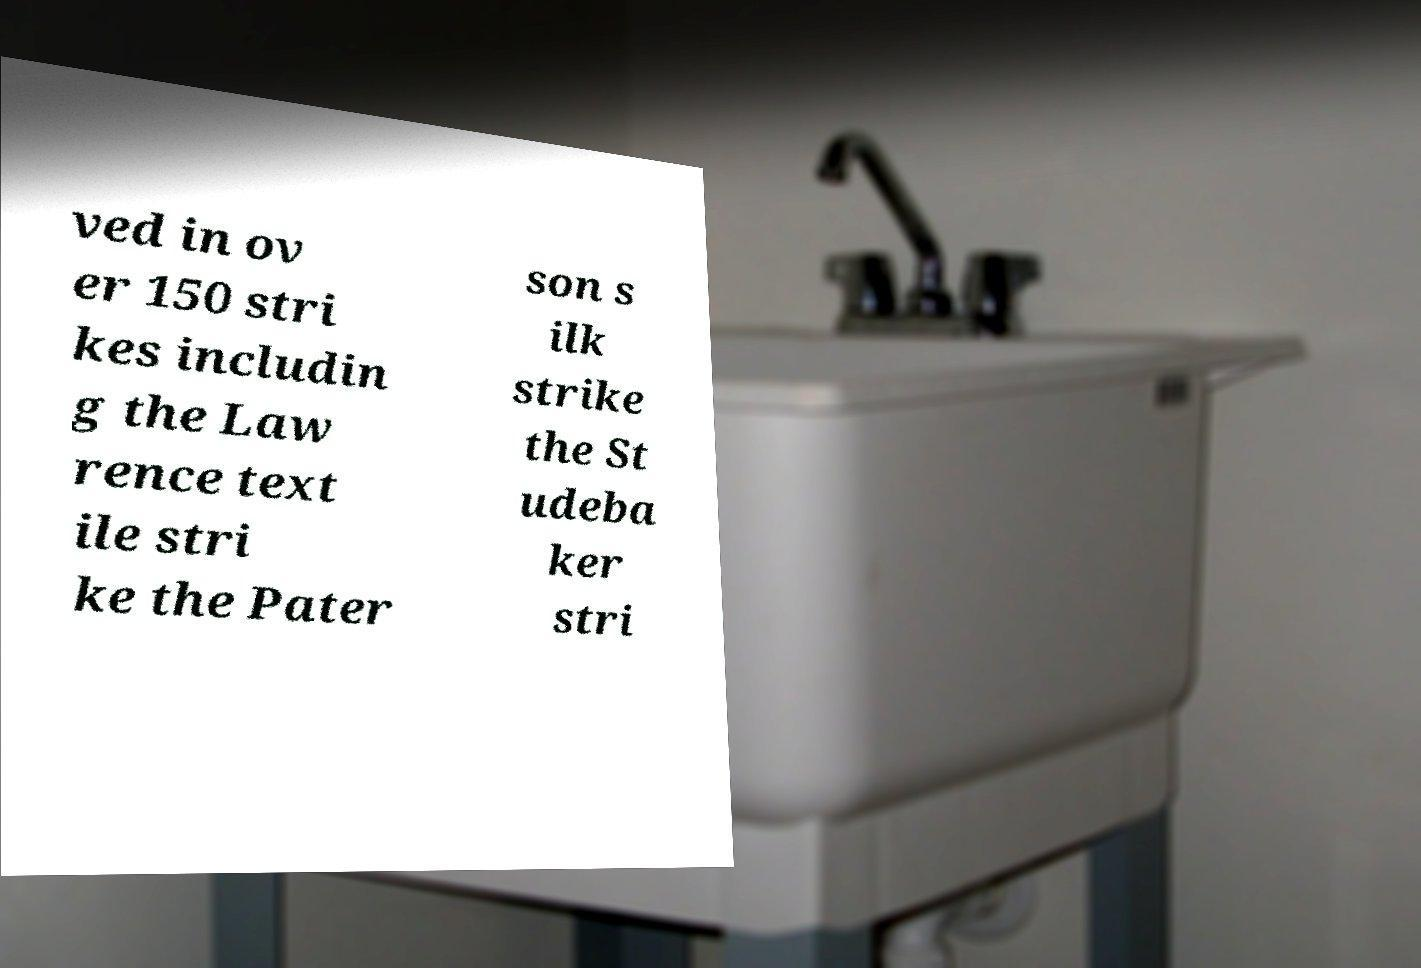For documentation purposes, I need the text within this image transcribed. Could you provide that? ved in ov er 150 stri kes includin g the Law rence text ile stri ke the Pater son s ilk strike the St udeba ker stri 